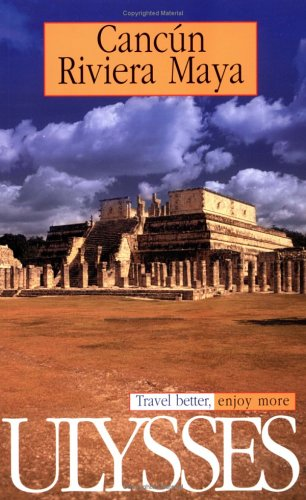Is this book related to Calendars? No, this book is not related to calendars. It is exclusively a travel guide, focusing on providing travel-related information and tips. 